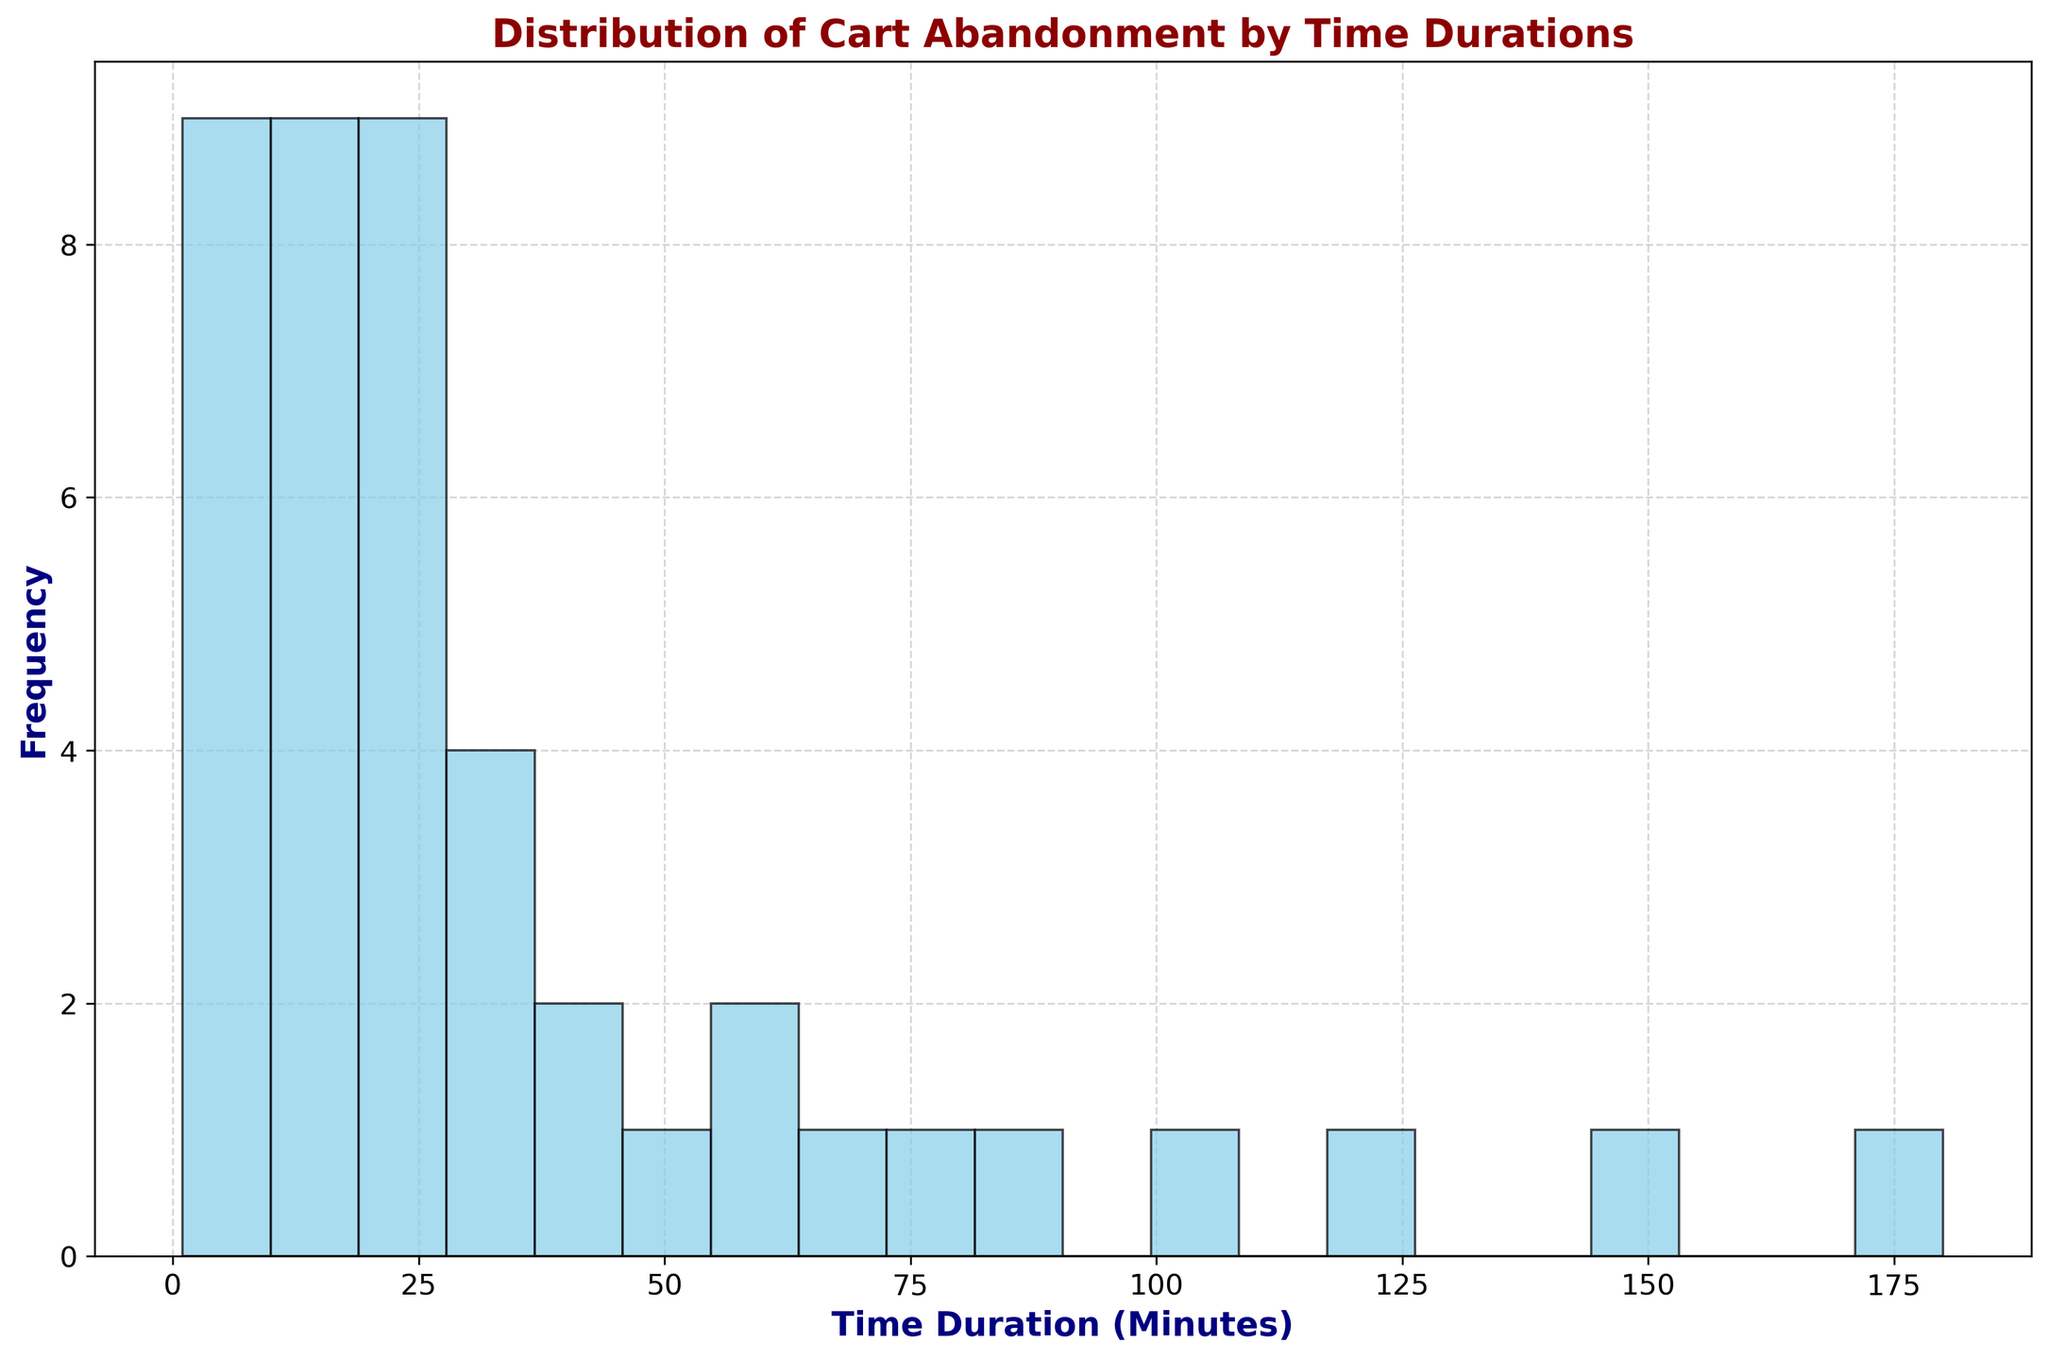What is the most common time duration for cart abandonment? To find the most common time duration for cart abandonment, look for the time duration bin with the highest bar in the histogram. This represents the time duration range with the highest frequency of occurrences.
Answer: Between 0 and 10 minutes Which time duration range has the lowest frequency of cart abandonment? To determine the time duration range with the lowest frequency of cart abandonment, look for the shortest bar in the histogram, indicating the lowest frequency.
Answer: Between 100 and 180 minutes What is the total range of time durations depicted in the histogram? To determine the total range of time durations, identify the lowest and highest values on the x-axis of the histogram. The range is the difference between these two values. The lowest value is 1 minute, and the highest value is 180 minutes.
Answer: 1 to 180 minutes Which time duration range shows a sudden increase in cart abandonment frequency? To identify a sudden increase, compare the heights of adjacent bars in the histogram. The range where the bar height increases significantly more than the previous bar indicates a sudden increase in frequency. The bar height increases noticeably more between 1-10 minutes compared to subsequent ranges.
Answer: Between 0 and 10 minutes How would you describe the overall trend observed in cart abandonment rates with increasing time duration? To describe the overall trend, observe the pattern formed by the bars from left to right. A consistent increase in bar heights indicates an increasing trend, while a decrease or consistency at the end suggests stabilization. The histogram shows a gradual increase in bar heights as the time duration increases, suggesting that cart abandonment rates increase as the time duration increases.
Answer: Increasing trend At what time duration does the cart abandonment rate first reach above 20%? Find the bar in the histogram that represents the time duration at which the cart abandonment rate is first above 20%.
Answer: Between 50 and 55 minutes Compare the frequency of cart abandonment in the duration range 10-20 minutes and 90-100 minutes. Which range has higher frequency? To compare the frequencies, observe the heights of the bars corresponding to the durations 10-20 minutes and 90-100 minutes. The range with the taller bars indicates a higher frequency.
Answer: 10-20 minutes Is the frequency of cart abandonment in the 70-80 minutes range higher or lower than in the 40-50 minutes range? Compare the heights of the bars in the 70-80 minutes range to those in the 40-50 minutes range. The taller bar indicates a higher frequency.
Answer: Lower What percentage of the total time duration bins are below 60 minutes? Count the total number of bins below 60 minutes by visually inspecting the histogram. Then count the total number of bins represented in the histogram. Calculate the percentage by dividing the count of bins below 60 minutes by the total count and multiplying by 100. Visual inspection indicates 12 bins below 60 minutes and a total of 20 bins. The percentage is (12/20)*100.
Answer: 60% Describe the symmetry, skewness, or any irregularities in the distribution pattern of the histogram. To describe symmetry or skewness, observe the shape of the histogram. A symmetric histogram will have bars of roughly equal height on either side of a central peak. Skewness is indicated if more bars are concentrated on one side. The distribution shows right (positive) skewness since more bars are clustered on the left side with a tail extending to the right.
Answer: Right-skewed 